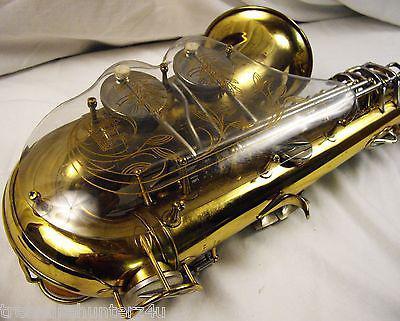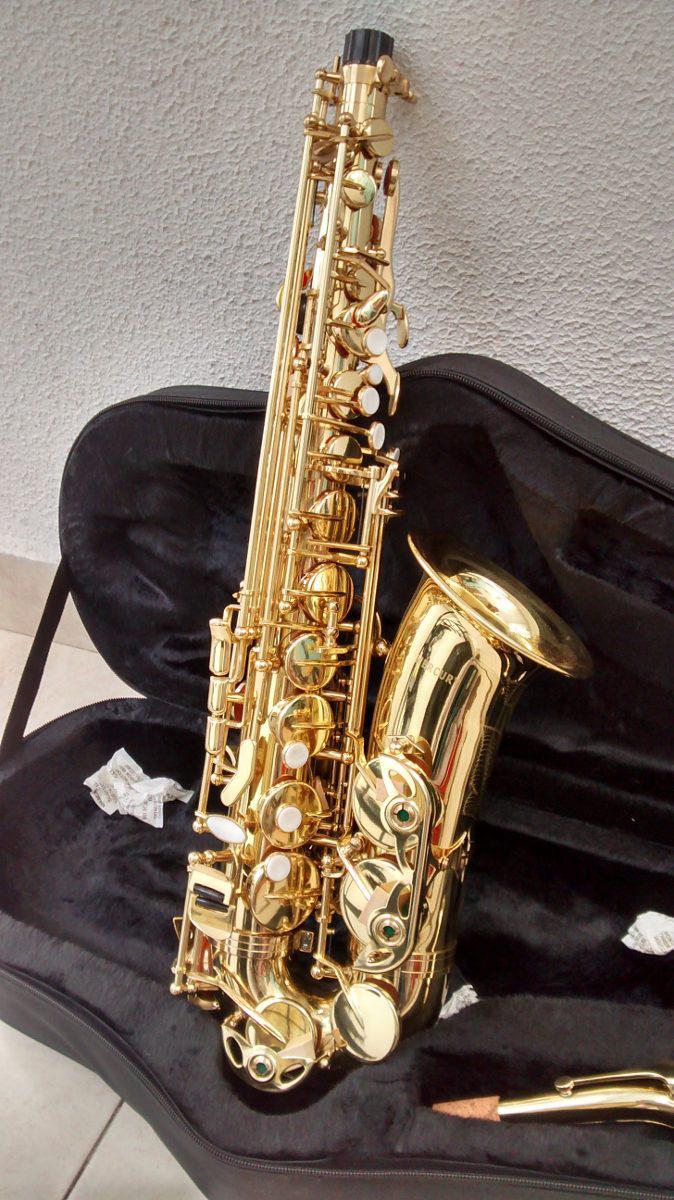The first image is the image on the left, the second image is the image on the right. Analyze the images presented: Is the assertion "In at least on image there is a brass saxophone facing left with it black case behind it." valid? Answer yes or no. Yes. 